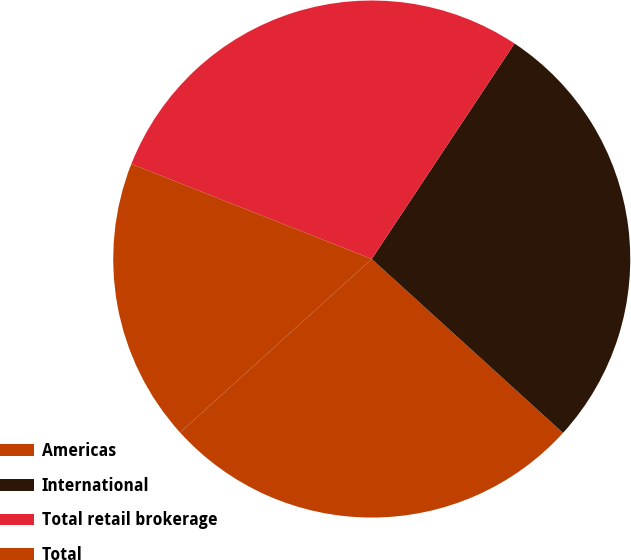Convert chart. <chart><loc_0><loc_0><loc_500><loc_500><pie_chart><fcel>Americas<fcel>International<fcel>Total retail brokerage<fcel>Total<nl><fcel>26.55%<fcel>27.43%<fcel>28.32%<fcel>17.7%<nl></chart> 